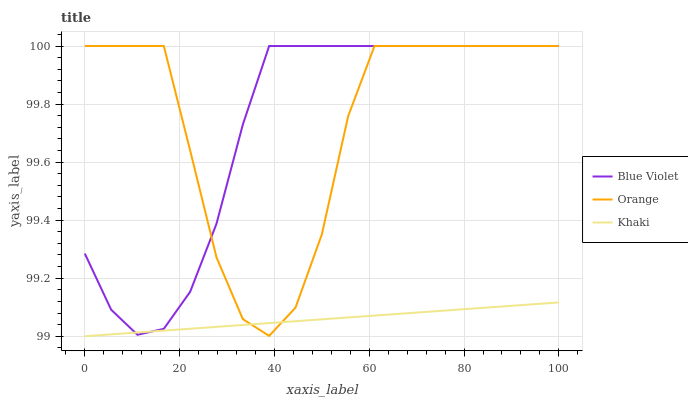Does Khaki have the minimum area under the curve?
Answer yes or no. Yes. Does Orange have the maximum area under the curve?
Answer yes or no. Yes. Does Blue Violet have the minimum area under the curve?
Answer yes or no. No. Does Blue Violet have the maximum area under the curve?
Answer yes or no. No. Is Khaki the smoothest?
Answer yes or no. Yes. Is Orange the roughest?
Answer yes or no. Yes. Is Blue Violet the smoothest?
Answer yes or no. No. Is Blue Violet the roughest?
Answer yes or no. No. Does Blue Violet have the lowest value?
Answer yes or no. No. Does Blue Violet have the highest value?
Answer yes or no. Yes. Does Khaki have the highest value?
Answer yes or no. No. Does Blue Violet intersect Orange?
Answer yes or no. Yes. Is Blue Violet less than Orange?
Answer yes or no. No. Is Blue Violet greater than Orange?
Answer yes or no. No. 